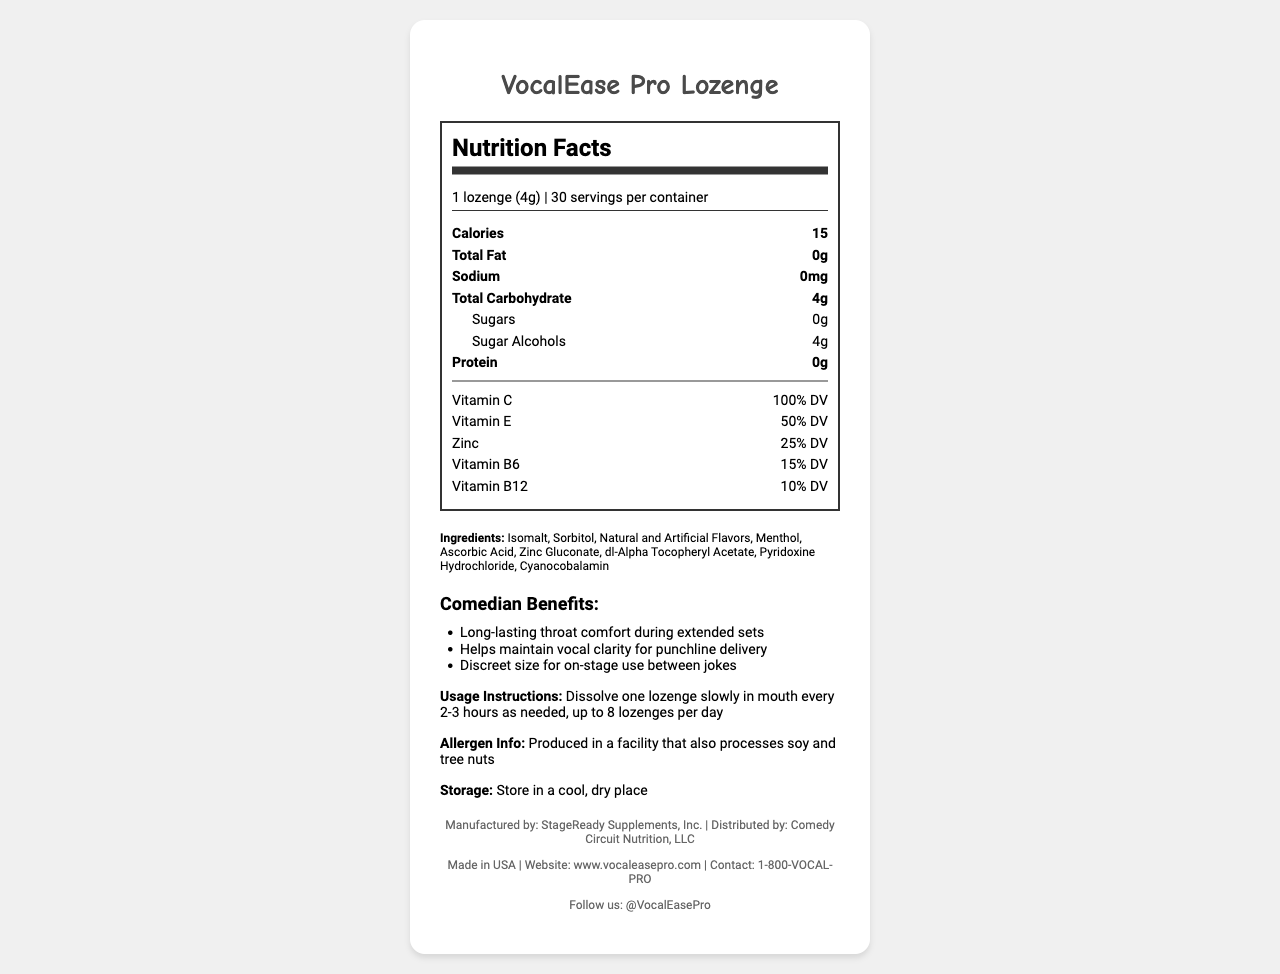what is the serving size of VocalEase Pro Lozenge? The serving size is listed at the top of the Nutrition Facts panel.
Answer: 1 lozenge (4g) how many servings are there per container? The text under the serving size specifies there are 30 servings per container.
Answer: 30 what is the amount of calories per serving? The calories per serving is clearly stated in the section under "Calories".
Answer: 15 how many grams of sugar alcohol are present in one serving? The Nutrition Facts label lists sugar alcohols as 4 grams under the carbohydrates section.
Answer: 4g which vitamins does the VocalEase Pro Lozenge provide and in what percentage of daily value (DV)? Each vitamin's percentage of daily value is detailed in the Nutrition Facts under the vitamins section.
Answer: Vitamin C - 100% DV, Vitamin E - 50% DV, Zinc - 25% DV, Vitamin B6 - 15% DV, Vitamin B12 - 10% DV what are the main benefits for comedians mentioned in the product information? The comedian benefits are listed in the product information section of the document.
Answer: Long-lasting throat comfort during extended sets, Helps maintain vocal clarity for punchline delivery, Discreet size for on-stage use between jokes what are the usage instructions for this product? The usage instructions are clearly provided in the product information section.
Answer: Dissolve one lozenge slowly in mouth every 2-3 hours as needed, up to 8 lozenges per day what type of facility is the product produced in? The allergen info states that the product is produced in a facility that also processes soy and tree nuts.
Answer: Produced in a facility that also processes soy and tree nuts how should the product be stored? The storage instructions advise keeping the product in a cool, dry place.
Answer: Store in a cool, dry place which company manufactures the VocalEase Pro Lozenge? A. StageReady Supplements, Inc. B. Comedy Circuit Nutrition, LLC C. VocalEase Labs D. Performer's Health Division The footer of the document states the manufacturer as StageReady Supplements, Inc.
Answer: A. StageReady Supplements, Inc. which vitamin is present in the highest percentage of daily value? A. Vitamin C B. Vitamin E C. Zinc D. Vitamin B6 Vitamin C is present at 100% DV, which is the highest among the listed vitamins.
Answer: A. Vitamin C is this product made in the USA? The footer confirms that the product is made in the USA.
Answer: Yes what is the purpose of the ingredients in the VocalEase Pro Lozenge? The document lists the ingredients but does not provide specific information about the purpose of each ingredient.
Answer: Cannot be determined provide a brief summary of the VocalEase Pro Lozenge's main features and benefits. The document presents details about the nutritional value, benefits, usage instructions, allergen info, storage, manufacturer, and contact information, emphasizing the product's suitability for performers like comedians.
Answer: The VocalEase Pro Lozenge provides essential vitamins and support for vocal health, especially designed for performers like comedians. It contains Vitamin C, Vitamin E, Zinc, Vitamin B6, and Vitamin B12, offering various percentages of daily values. The product claims to support vocal cord health, soothe throat irritation, and promote clear voice production. It is convenient for on-stage use due to its discreet size and provides long-lasting comfort for extended sets. Usage instructions, allergen info, storage information, manufacturer details, and contact are also provided. 